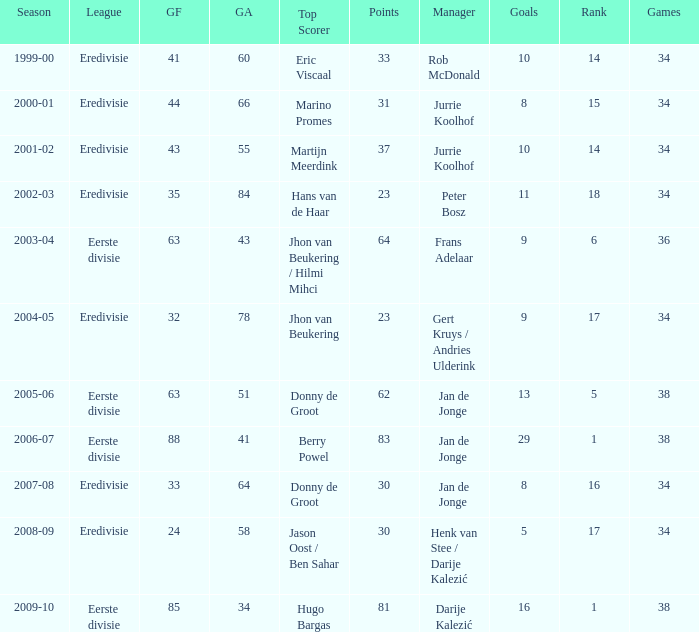Who is the top scorer where gf is 41? Eric Viscaal. Could you parse the entire table as a dict? {'header': ['Season', 'League', 'GF', 'GA', 'Top Scorer', 'Points', 'Manager', 'Goals', 'Rank', 'Games'], 'rows': [['1999-00', 'Eredivisie', '41', '60', 'Eric Viscaal', '33', 'Rob McDonald', '10', '14', '34'], ['2000-01', 'Eredivisie', '44', '66', 'Marino Promes', '31', 'Jurrie Koolhof', '8', '15', '34'], ['2001-02', 'Eredivisie', '43', '55', 'Martijn Meerdink', '37', 'Jurrie Koolhof', '10', '14', '34'], ['2002-03', 'Eredivisie', '35', '84', 'Hans van de Haar', '23', 'Peter Bosz', '11', '18', '34'], ['2003-04', 'Eerste divisie', '63', '43', 'Jhon van Beukering / Hilmi Mihci', '64', 'Frans Adelaar', '9', '6', '36'], ['2004-05', 'Eredivisie', '32', '78', 'Jhon van Beukering', '23', 'Gert Kruys / Andries Ulderink', '9', '17', '34'], ['2005-06', 'Eerste divisie', '63', '51', 'Donny de Groot', '62', 'Jan de Jonge', '13', '5', '38'], ['2006-07', 'Eerste divisie', '88', '41', 'Berry Powel', '83', 'Jan de Jonge', '29', '1', '38'], ['2007-08', 'Eredivisie', '33', '64', 'Donny de Groot', '30', 'Jan de Jonge', '8', '16', '34'], ['2008-09', 'Eredivisie', '24', '58', 'Jason Oost / Ben Sahar', '30', 'Henk van Stee / Darije Kalezić', '5', '17', '34'], ['2009-10', 'Eerste divisie', '85', '34', 'Hugo Bargas', '81', 'Darije Kalezić', '16', '1', '38']]} 